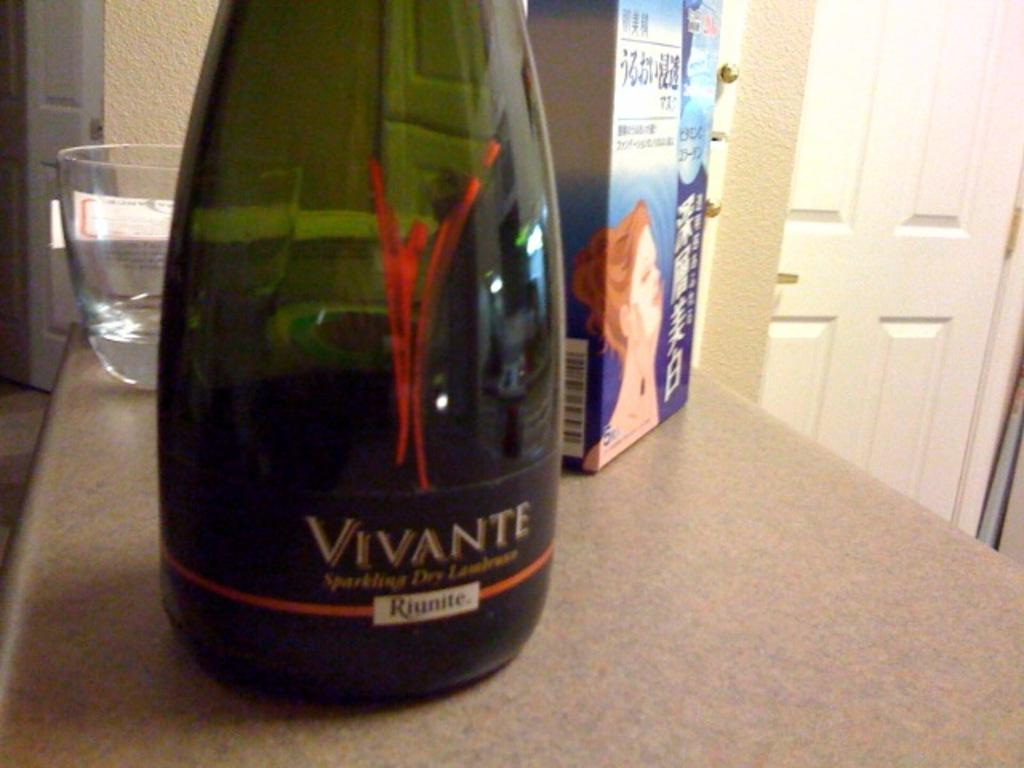What is on the table in the image? There is a bottle and a glass on the table. What else can be seen on the table? There is a cover packet on the table. What can be seen in the background of the image? There are doors and walls visible in the background. What type of haircut is the bottle getting in the image? There is no haircut being performed in the image, as the main subject is a bottle on a table. 